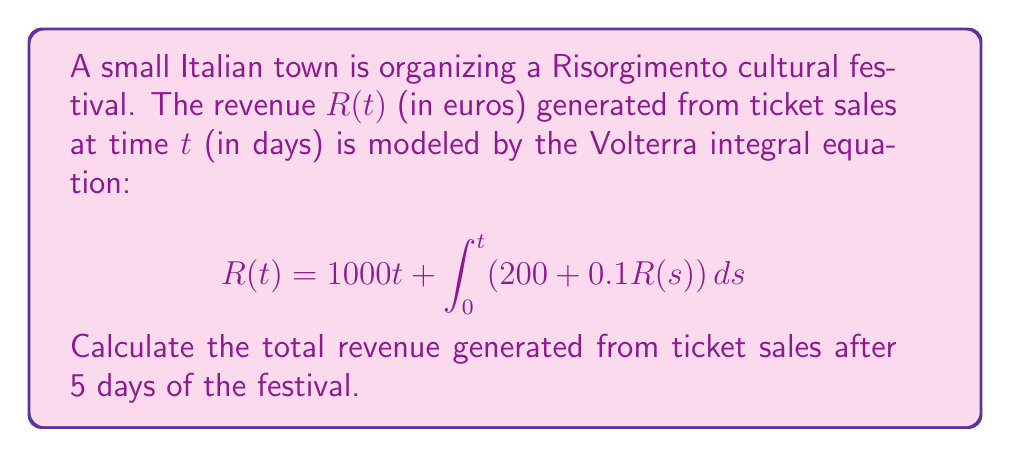Can you answer this question? To solve this Volterra integral equation, we'll follow these steps:

1) First, we differentiate both sides of the equation with respect to $t$:

   $$\frac{dR}{dt} = 1000 + 200 + 0.1R(t)$$

2) Rearrange the equation:

   $$\frac{dR}{dt} - 0.1R = 1200$$

3) This is a first-order linear differential equation. The general solution is:

   $$R(t) = C e^{0.1t} + 12000$$

4) To find $C$, we use the initial condition $R(0) = 0$:

   $$0 = C + 12000$$
   $$C = -12000$$

5) Therefore, the particular solution is:

   $$R(t) = 12000(e^{0.1t} - 1)$$

6) To find the revenue after 5 days, we substitute $t = 5$:

   $$R(5) = 12000(e^{0.5} - 1)$$

7) Calculate the final value:

   $$R(5) = 12000(1.6487 - 1) = 7784.4$$
Answer: €7,784.40 